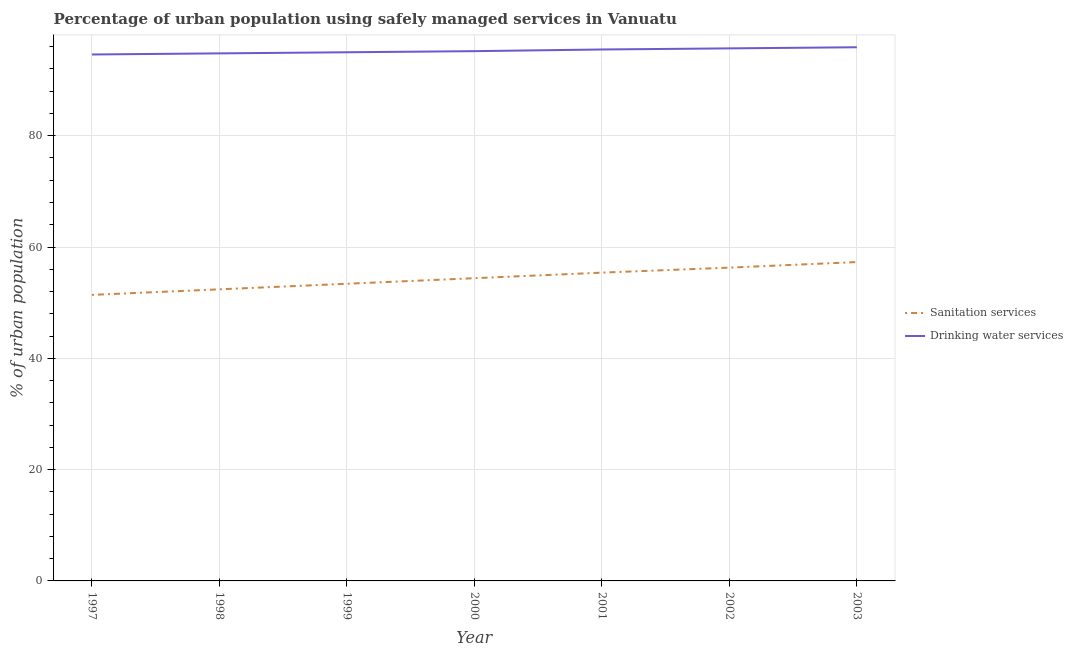What is the percentage of urban population who used sanitation services in 1997?
Keep it short and to the point. 51.4. Across all years, what is the maximum percentage of urban population who used drinking water services?
Provide a succinct answer. 95.9. Across all years, what is the minimum percentage of urban population who used drinking water services?
Offer a very short reply. 94.6. In which year was the percentage of urban population who used sanitation services minimum?
Provide a short and direct response. 1997. What is the total percentage of urban population who used drinking water services in the graph?
Give a very brief answer. 666.7. What is the difference between the percentage of urban population who used sanitation services in 2001 and that in 2003?
Offer a very short reply. -1.9. What is the difference between the percentage of urban population who used drinking water services in 2002 and the percentage of urban population who used sanitation services in 2001?
Offer a terse response. 40.3. What is the average percentage of urban population who used drinking water services per year?
Provide a succinct answer. 95.24. In the year 2003, what is the difference between the percentage of urban population who used drinking water services and percentage of urban population who used sanitation services?
Your answer should be very brief. 38.6. In how many years, is the percentage of urban population who used drinking water services greater than 44 %?
Your answer should be very brief. 7. What is the ratio of the percentage of urban population who used drinking water services in 1997 to that in 2001?
Keep it short and to the point. 0.99. Is the percentage of urban population who used drinking water services in 1997 less than that in 1998?
Your answer should be compact. Yes. Is the difference between the percentage of urban population who used drinking water services in 2002 and 2003 greater than the difference between the percentage of urban population who used sanitation services in 2002 and 2003?
Make the answer very short. Yes. What is the difference between the highest and the second highest percentage of urban population who used drinking water services?
Give a very brief answer. 0.2. What is the difference between the highest and the lowest percentage of urban population who used drinking water services?
Keep it short and to the point. 1.3. Does the percentage of urban population who used drinking water services monotonically increase over the years?
Ensure brevity in your answer.  Yes. Is the percentage of urban population who used drinking water services strictly less than the percentage of urban population who used sanitation services over the years?
Offer a very short reply. No. How many years are there in the graph?
Offer a very short reply. 7. What is the difference between two consecutive major ticks on the Y-axis?
Give a very brief answer. 20. Are the values on the major ticks of Y-axis written in scientific E-notation?
Your answer should be very brief. No. Does the graph contain grids?
Provide a short and direct response. Yes. Where does the legend appear in the graph?
Offer a terse response. Center right. How many legend labels are there?
Make the answer very short. 2. What is the title of the graph?
Offer a very short reply. Percentage of urban population using safely managed services in Vanuatu. What is the label or title of the Y-axis?
Your answer should be compact. % of urban population. What is the % of urban population of Sanitation services in 1997?
Your response must be concise. 51.4. What is the % of urban population of Drinking water services in 1997?
Offer a very short reply. 94.6. What is the % of urban population in Sanitation services in 1998?
Your answer should be very brief. 52.4. What is the % of urban population in Drinking water services in 1998?
Keep it short and to the point. 94.8. What is the % of urban population of Sanitation services in 1999?
Your answer should be compact. 53.4. What is the % of urban population of Drinking water services in 1999?
Offer a very short reply. 95. What is the % of urban population in Sanitation services in 2000?
Your answer should be very brief. 54.4. What is the % of urban population in Drinking water services in 2000?
Ensure brevity in your answer.  95.2. What is the % of urban population in Sanitation services in 2001?
Keep it short and to the point. 55.4. What is the % of urban population in Drinking water services in 2001?
Keep it short and to the point. 95.5. What is the % of urban population in Sanitation services in 2002?
Give a very brief answer. 56.3. What is the % of urban population of Drinking water services in 2002?
Make the answer very short. 95.7. What is the % of urban population of Sanitation services in 2003?
Your answer should be very brief. 57.3. What is the % of urban population of Drinking water services in 2003?
Your answer should be compact. 95.9. Across all years, what is the maximum % of urban population in Sanitation services?
Provide a succinct answer. 57.3. Across all years, what is the maximum % of urban population in Drinking water services?
Your response must be concise. 95.9. Across all years, what is the minimum % of urban population in Sanitation services?
Provide a short and direct response. 51.4. Across all years, what is the minimum % of urban population in Drinking water services?
Your response must be concise. 94.6. What is the total % of urban population in Sanitation services in the graph?
Your response must be concise. 380.6. What is the total % of urban population in Drinking water services in the graph?
Provide a succinct answer. 666.7. What is the difference between the % of urban population of Drinking water services in 1997 and that in 1999?
Ensure brevity in your answer.  -0.4. What is the difference between the % of urban population of Drinking water services in 1997 and that in 2000?
Your response must be concise. -0.6. What is the difference between the % of urban population of Sanitation services in 1997 and that in 2001?
Provide a short and direct response. -4. What is the difference between the % of urban population of Drinking water services in 1997 and that in 2003?
Provide a short and direct response. -1.3. What is the difference between the % of urban population in Sanitation services in 1998 and that in 1999?
Give a very brief answer. -1. What is the difference between the % of urban population of Sanitation services in 1998 and that in 2000?
Your answer should be very brief. -2. What is the difference between the % of urban population in Sanitation services in 1998 and that in 2001?
Your answer should be very brief. -3. What is the difference between the % of urban population of Sanitation services in 1998 and that in 2002?
Offer a very short reply. -3.9. What is the difference between the % of urban population of Drinking water services in 1998 and that in 2002?
Give a very brief answer. -0.9. What is the difference between the % of urban population in Drinking water services in 1998 and that in 2003?
Keep it short and to the point. -1.1. What is the difference between the % of urban population in Sanitation services in 1999 and that in 2000?
Keep it short and to the point. -1. What is the difference between the % of urban population in Sanitation services in 1999 and that in 2002?
Offer a very short reply. -2.9. What is the difference between the % of urban population in Sanitation services in 1999 and that in 2003?
Keep it short and to the point. -3.9. What is the difference between the % of urban population in Drinking water services in 1999 and that in 2003?
Offer a very short reply. -0.9. What is the difference between the % of urban population of Sanitation services in 2000 and that in 2001?
Make the answer very short. -1. What is the difference between the % of urban population of Sanitation services in 2000 and that in 2003?
Your answer should be compact. -2.9. What is the difference between the % of urban population of Sanitation services in 2001 and that in 2002?
Your response must be concise. -0.9. What is the difference between the % of urban population in Drinking water services in 2001 and that in 2003?
Offer a very short reply. -0.4. What is the difference between the % of urban population of Sanitation services in 1997 and the % of urban population of Drinking water services in 1998?
Keep it short and to the point. -43.4. What is the difference between the % of urban population of Sanitation services in 1997 and the % of urban population of Drinking water services in 1999?
Your response must be concise. -43.6. What is the difference between the % of urban population of Sanitation services in 1997 and the % of urban population of Drinking water services in 2000?
Provide a succinct answer. -43.8. What is the difference between the % of urban population in Sanitation services in 1997 and the % of urban population in Drinking water services in 2001?
Provide a succinct answer. -44.1. What is the difference between the % of urban population of Sanitation services in 1997 and the % of urban population of Drinking water services in 2002?
Offer a very short reply. -44.3. What is the difference between the % of urban population in Sanitation services in 1997 and the % of urban population in Drinking water services in 2003?
Give a very brief answer. -44.5. What is the difference between the % of urban population in Sanitation services in 1998 and the % of urban population in Drinking water services in 1999?
Your response must be concise. -42.6. What is the difference between the % of urban population in Sanitation services in 1998 and the % of urban population in Drinking water services in 2000?
Your answer should be very brief. -42.8. What is the difference between the % of urban population of Sanitation services in 1998 and the % of urban population of Drinking water services in 2001?
Give a very brief answer. -43.1. What is the difference between the % of urban population in Sanitation services in 1998 and the % of urban population in Drinking water services in 2002?
Your answer should be very brief. -43.3. What is the difference between the % of urban population in Sanitation services in 1998 and the % of urban population in Drinking water services in 2003?
Your response must be concise. -43.5. What is the difference between the % of urban population in Sanitation services in 1999 and the % of urban population in Drinking water services in 2000?
Provide a succinct answer. -41.8. What is the difference between the % of urban population in Sanitation services in 1999 and the % of urban population in Drinking water services in 2001?
Give a very brief answer. -42.1. What is the difference between the % of urban population of Sanitation services in 1999 and the % of urban population of Drinking water services in 2002?
Provide a short and direct response. -42.3. What is the difference between the % of urban population of Sanitation services in 1999 and the % of urban population of Drinking water services in 2003?
Ensure brevity in your answer.  -42.5. What is the difference between the % of urban population in Sanitation services in 2000 and the % of urban population in Drinking water services in 2001?
Offer a terse response. -41.1. What is the difference between the % of urban population in Sanitation services in 2000 and the % of urban population in Drinking water services in 2002?
Offer a terse response. -41.3. What is the difference between the % of urban population in Sanitation services in 2000 and the % of urban population in Drinking water services in 2003?
Give a very brief answer. -41.5. What is the difference between the % of urban population in Sanitation services in 2001 and the % of urban population in Drinking water services in 2002?
Make the answer very short. -40.3. What is the difference between the % of urban population of Sanitation services in 2001 and the % of urban population of Drinking water services in 2003?
Ensure brevity in your answer.  -40.5. What is the difference between the % of urban population in Sanitation services in 2002 and the % of urban population in Drinking water services in 2003?
Your answer should be very brief. -39.6. What is the average % of urban population in Sanitation services per year?
Make the answer very short. 54.37. What is the average % of urban population in Drinking water services per year?
Ensure brevity in your answer.  95.24. In the year 1997, what is the difference between the % of urban population in Sanitation services and % of urban population in Drinking water services?
Ensure brevity in your answer.  -43.2. In the year 1998, what is the difference between the % of urban population in Sanitation services and % of urban population in Drinking water services?
Your response must be concise. -42.4. In the year 1999, what is the difference between the % of urban population in Sanitation services and % of urban population in Drinking water services?
Your answer should be very brief. -41.6. In the year 2000, what is the difference between the % of urban population in Sanitation services and % of urban population in Drinking water services?
Your answer should be very brief. -40.8. In the year 2001, what is the difference between the % of urban population of Sanitation services and % of urban population of Drinking water services?
Give a very brief answer. -40.1. In the year 2002, what is the difference between the % of urban population of Sanitation services and % of urban population of Drinking water services?
Your response must be concise. -39.4. In the year 2003, what is the difference between the % of urban population of Sanitation services and % of urban population of Drinking water services?
Keep it short and to the point. -38.6. What is the ratio of the % of urban population in Sanitation services in 1997 to that in 1998?
Offer a very short reply. 0.98. What is the ratio of the % of urban population of Sanitation services in 1997 to that in 1999?
Offer a terse response. 0.96. What is the ratio of the % of urban population in Drinking water services in 1997 to that in 1999?
Offer a terse response. 1. What is the ratio of the % of urban population of Sanitation services in 1997 to that in 2000?
Ensure brevity in your answer.  0.94. What is the ratio of the % of urban population in Sanitation services in 1997 to that in 2001?
Offer a terse response. 0.93. What is the ratio of the % of urban population of Drinking water services in 1997 to that in 2001?
Ensure brevity in your answer.  0.99. What is the ratio of the % of urban population of Sanitation services in 1997 to that in 2002?
Your response must be concise. 0.91. What is the ratio of the % of urban population in Sanitation services in 1997 to that in 2003?
Your answer should be very brief. 0.9. What is the ratio of the % of urban population in Drinking water services in 1997 to that in 2003?
Provide a short and direct response. 0.99. What is the ratio of the % of urban population of Sanitation services in 1998 to that in 1999?
Give a very brief answer. 0.98. What is the ratio of the % of urban population of Sanitation services in 1998 to that in 2000?
Offer a very short reply. 0.96. What is the ratio of the % of urban population in Sanitation services in 1998 to that in 2001?
Make the answer very short. 0.95. What is the ratio of the % of urban population in Drinking water services in 1998 to that in 2001?
Your answer should be very brief. 0.99. What is the ratio of the % of urban population in Sanitation services in 1998 to that in 2002?
Keep it short and to the point. 0.93. What is the ratio of the % of urban population in Drinking water services in 1998 to that in 2002?
Your answer should be very brief. 0.99. What is the ratio of the % of urban population in Sanitation services in 1998 to that in 2003?
Your answer should be compact. 0.91. What is the ratio of the % of urban population in Sanitation services in 1999 to that in 2000?
Offer a terse response. 0.98. What is the ratio of the % of urban population of Sanitation services in 1999 to that in 2001?
Make the answer very short. 0.96. What is the ratio of the % of urban population of Drinking water services in 1999 to that in 2001?
Give a very brief answer. 0.99. What is the ratio of the % of urban population in Sanitation services in 1999 to that in 2002?
Give a very brief answer. 0.95. What is the ratio of the % of urban population in Drinking water services in 1999 to that in 2002?
Provide a short and direct response. 0.99. What is the ratio of the % of urban population in Sanitation services in 1999 to that in 2003?
Your answer should be very brief. 0.93. What is the ratio of the % of urban population of Drinking water services in 1999 to that in 2003?
Offer a terse response. 0.99. What is the ratio of the % of urban population in Sanitation services in 2000 to that in 2001?
Provide a succinct answer. 0.98. What is the ratio of the % of urban population of Sanitation services in 2000 to that in 2002?
Offer a very short reply. 0.97. What is the ratio of the % of urban population in Drinking water services in 2000 to that in 2002?
Offer a terse response. 0.99. What is the ratio of the % of urban population in Sanitation services in 2000 to that in 2003?
Offer a terse response. 0.95. What is the ratio of the % of urban population in Sanitation services in 2001 to that in 2002?
Your answer should be very brief. 0.98. What is the ratio of the % of urban population of Drinking water services in 2001 to that in 2002?
Give a very brief answer. 1. What is the ratio of the % of urban population of Sanitation services in 2001 to that in 2003?
Your response must be concise. 0.97. What is the ratio of the % of urban population of Sanitation services in 2002 to that in 2003?
Your answer should be very brief. 0.98. What is the difference between the highest and the second highest % of urban population of Sanitation services?
Your response must be concise. 1. What is the difference between the highest and the lowest % of urban population of Sanitation services?
Offer a very short reply. 5.9. What is the difference between the highest and the lowest % of urban population of Drinking water services?
Make the answer very short. 1.3. 